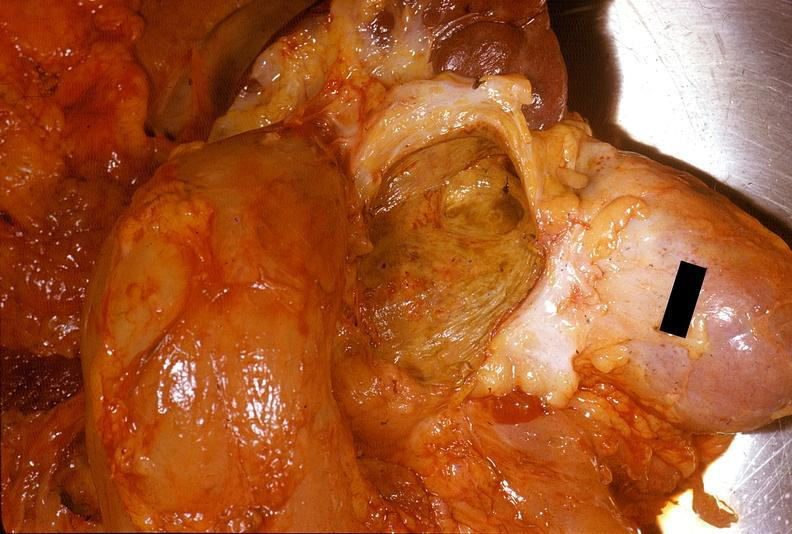does meningioma show chronic pancreatitis with cyst formation?
Answer the question using a single word or phrase. No 